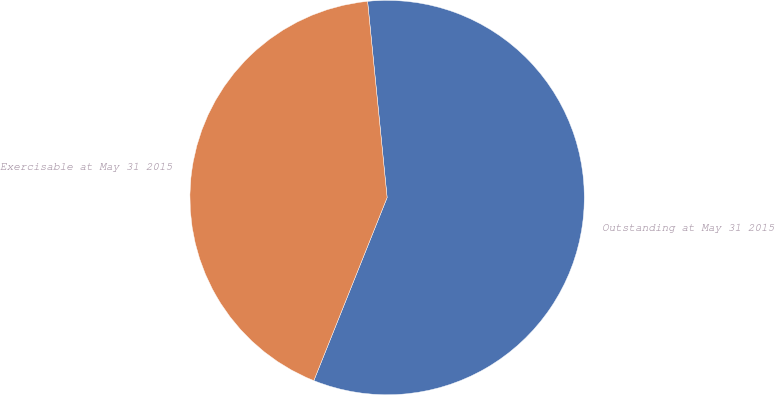Convert chart. <chart><loc_0><loc_0><loc_500><loc_500><pie_chart><fcel>Outstanding at May 31 2015<fcel>Exercisable at May 31 2015<nl><fcel>57.64%<fcel>42.36%<nl></chart> 